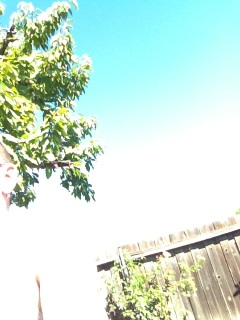What time of day does it appear to be in this image? The brightness and blue color of the sky suggest it is likely taken during the day when the sun is high, which is consistent with the overexposed areas of the photo, indicating a strong light source like the midday sun. 